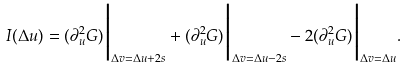<formula> <loc_0><loc_0><loc_500><loc_500>I ( \Delta u ) = ( \partial _ { u } ^ { 2 } G ) \Big | _ { \Delta v = \Delta u + 2 s } + ( \partial _ { u } ^ { 2 } G ) \Big | _ { \Delta v = \Delta u - 2 s } - 2 ( \partial _ { u } ^ { 2 } G ) \Big | _ { \Delta v = \Delta u } .</formula> 